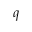<formula> <loc_0><loc_0><loc_500><loc_500>q</formula> 